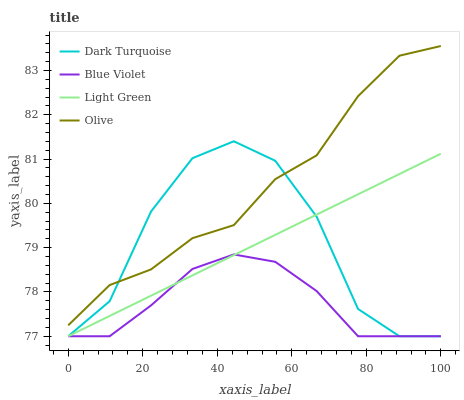Does Blue Violet have the minimum area under the curve?
Answer yes or no. Yes. Does Olive have the maximum area under the curve?
Answer yes or no. Yes. Does Dark Turquoise have the minimum area under the curve?
Answer yes or no. No. Does Dark Turquoise have the maximum area under the curve?
Answer yes or no. No. Is Light Green the smoothest?
Answer yes or no. Yes. Is Dark Turquoise the roughest?
Answer yes or no. Yes. Is Dark Turquoise the smoothest?
Answer yes or no. No. Is Light Green the roughest?
Answer yes or no. No. Does Dark Turquoise have the lowest value?
Answer yes or no. Yes. Does Olive have the highest value?
Answer yes or no. Yes. Does Dark Turquoise have the highest value?
Answer yes or no. No. Is Blue Violet less than Olive?
Answer yes or no. Yes. Is Olive greater than Blue Violet?
Answer yes or no. Yes. Does Dark Turquoise intersect Blue Violet?
Answer yes or no. Yes. Is Dark Turquoise less than Blue Violet?
Answer yes or no. No. Is Dark Turquoise greater than Blue Violet?
Answer yes or no. No. Does Blue Violet intersect Olive?
Answer yes or no. No. 